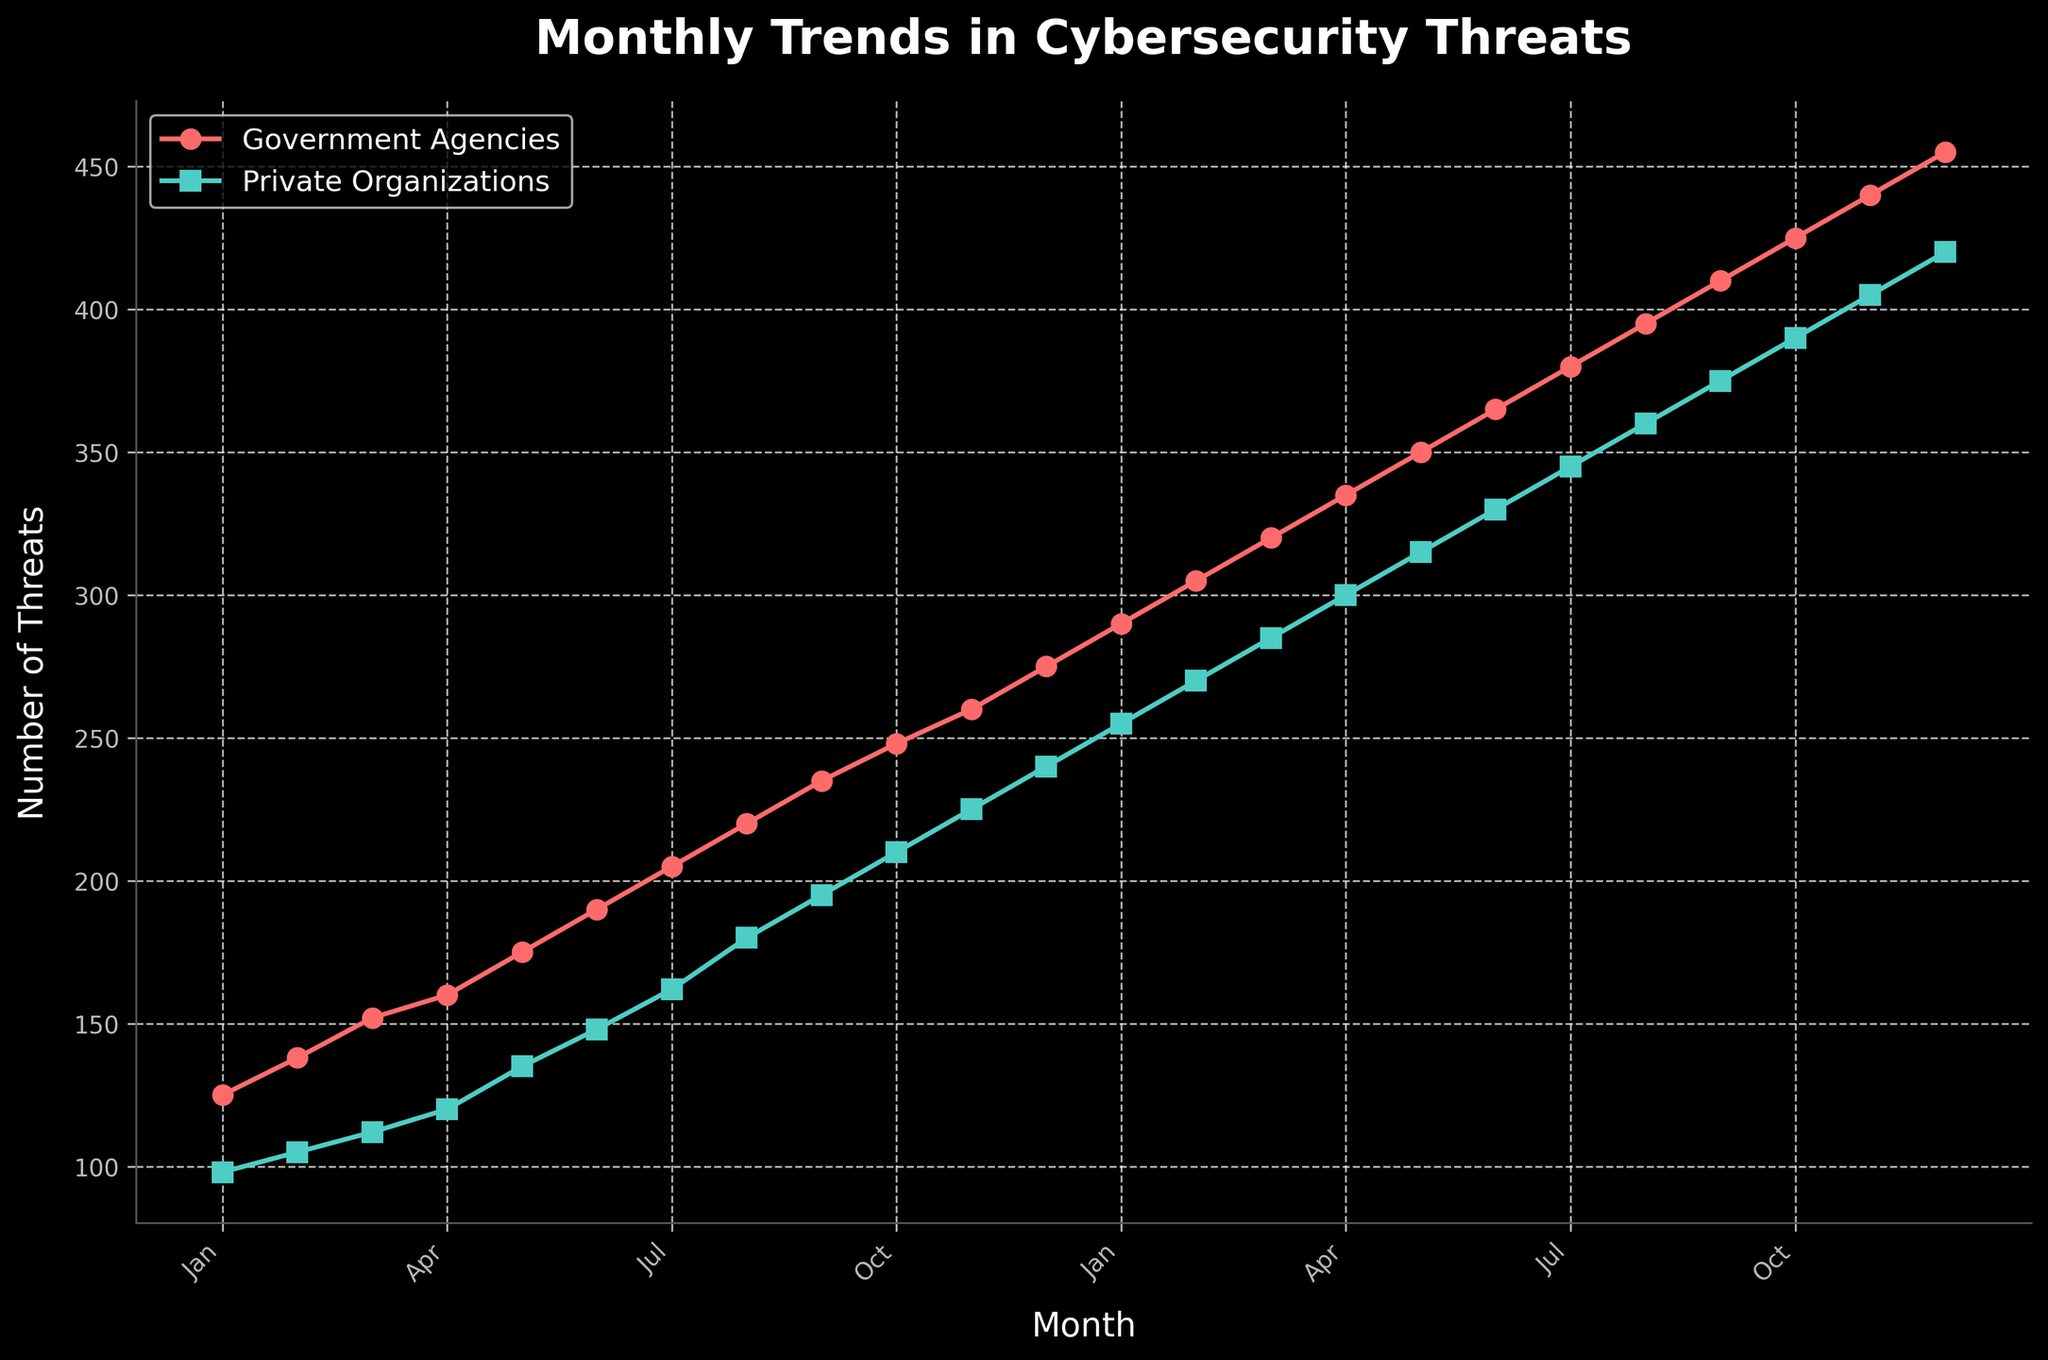What month shows the largest difference in threats between government agencies and private organizations? To find the month with the largest difference, look at the vertical gaps between the lines in the graph. The largest gap is in December where the government agencies have 455 threats and private organizations have 420 threats. Thus, the difference is 455 - 420 = 35.
Answer: December What is the average number of threats for government agencies over the last six months of the data? To calculate the average, sum the number of threats for government agencies from Jul to Dec (380, 395, 410, 425, 440, 455) and divide by 6. The sum is 380 + 395 + 410 + 425 + 440 + 455 = 2505. Dividing this by 6 gives an average of 2505 / 6 = 417.5.
Answer: 417.5 Which organization faced more cybersecurity threats in March of the first year, and by how much? Look at the values in March. Government agencies have 152 threats, while private organizations have 112. The difference is 152 - 112 = 40.
Answer: Government Agencies, 40 threats How does the threat trend differ between both organizations over the two-year period? Visually compare the gradient of both lines. Both lines show an increasing trend, but the government agencies show a consistently higher and somewhat steeper increasing trend throughout the period compared to private organizations.
Answer: Government agencies show a steeper increasing trend What is the cumulative number of threats targeting private organizations over the two years? Sum all the monthly threats for private organizations over the two years. 98 + 105 + 112 + 120 + 135 + 148 + 162 + 180 + 195 + 210 + 225 + 240 + 255 + 270 + 285 + 300 + 315 + 330 + 345 + 360 + 375 + 390 + 405 + 420 = 5830.
Answer: 5830 In which month did government agencies first surpass 300 threats? Look for the first month where the value for government agencies exceeds 300. This occurs in March of the second year with 320 threats.
Answer: March of the second year What is the trend of the number of cybersecurity threats from August to October of the second year for private organizations? Observe the graph section from August to October of the second year for private organizations. The number increases from 360 in August, to 375 in September, and 390 in October. It shows a steady increasing trend over this period.
Answer: Increasing trend 